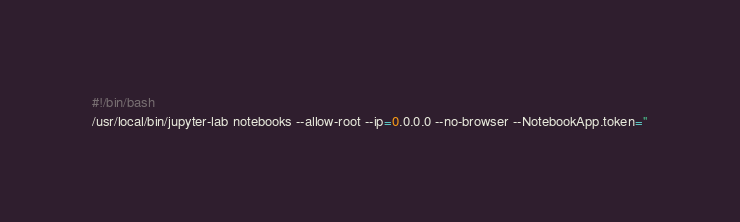Convert code to text. <code><loc_0><loc_0><loc_500><loc_500><_Bash_>#!/bin/bash
/usr/local/bin/jupyter-lab notebooks --allow-root --ip=0.0.0.0 --no-browser --NotebookApp.token=''
</code> 